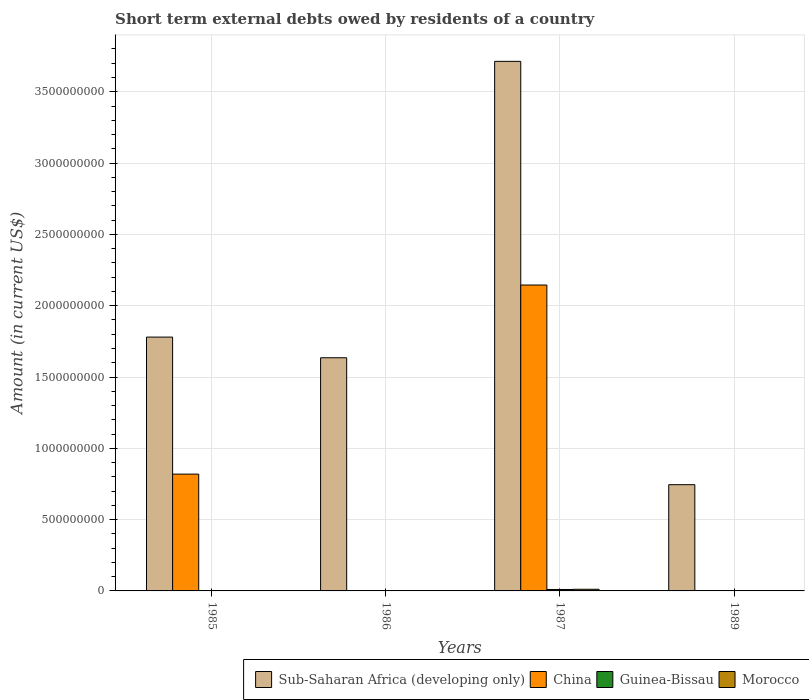How many different coloured bars are there?
Provide a succinct answer. 4. How many bars are there on the 3rd tick from the right?
Keep it short and to the point. 1. What is the label of the 2nd group of bars from the left?
Offer a terse response. 1986. What is the amount of short-term external debts owed by residents in Sub-Saharan Africa (developing only) in 1986?
Keep it short and to the point. 1.63e+09. Across all years, what is the maximum amount of short-term external debts owed by residents in Sub-Saharan Africa (developing only)?
Provide a short and direct response. 3.71e+09. In which year was the amount of short-term external debts owed by residents in China maximum?
Provide a short and direct response. 1987. What is the total amount of short-term external debts owed by residents in China in the graph?
Make the answer very short. 2.96e+09. What is the difference between the amount of short-term external debts owed by residents in Sub-Saharan Africa (developing only) in 1985 and that in 1986?
Offer a terse response. 1.45e+08. What is the difference between the amount of short-term external debts owed by residents in China in 1987 and the amount of short-term external debts owed by residents in Guinea-Bissau in 1989?
Provide a short and direct response. 2.14e+09. What is the average amount of short-term external debts owed by residents in Sub-Saharan Africa (developing only) per year?
Your answer should be very brief. 1.97e+09. In the year 1987, what is the difference between the amount of short-term external debts owed by residents in China and amount of short-term external debts owed by residents in Guinea-Bissau?
Your answer should be very brief. 2.13e+09. In how many years, is the amount of short-term external debts owed by residents in Morocco greater than 1300000000 US$?
Ensure brevity in your answer.  0. What is the difference between the highest and the lowest amount of short-term external debts owed by residents in China?
Make the answer very short. 2.14e+09. Is the sum of the amount of short-term external debts owed by residents in Sub-Saharan Africa (developing only) in 1985 and 1986 greater than the maximum amount of short-term external debts owed by residents in Guinea-Bissau across all years?
Your answer should be compact. Yes. Is it the case that in every year, the sum of the amount of short-term external debts owed by residents in Sub-Saharan Africa (developing only) and amount of short-term external debts owed by residents in Morocco is greater than the sum of amount of short-term external debts owed by residents in Guinea-Bissau and amount of short-term external debts owed by residents in China?
Give a very brief answer. Yes. How many bars are there?
Provide a short and direct response. 8. How many years are there in the graph?
Keep it short and to the point. 4. Does the graph contain grids?
Your answer should be very brief. Yes. Where does the legend appear in the graph?
Give a very brief answer. Bottom right. How many legend labels are there?
Provide a short and direct response. 4. What is the title of the graph?
Make the answer very short. Short term external debts owed by residents of a country. Does "Kiribati" appear as one of the legend labels in the graph?
Keep it short and to the point. No. What is the Amount (in current US$) of Sub-Saharan Africa (developing only) in 1985?
Your response must be concise. 1.78e+09. What is the Amount (in current US$) of China in 1985?
Your response must be concise. 8.19e+08. What is the Amount (in current US$) in Morocco in 1985?
Your response must be concise. 0. What is the Amount (in current US$) in Sub-Saharan Africa (developing only) in 1986?
Ensure brevity in your answer.  1.63e+09. What is the Amount (in current US$) of Morocco in 1986?
Keep it short and to the point. 0. What is the Amount (in current US$) in Sub-Saharan Africa (developing only) in 1987?
Make the answer very short. 3.71e+09. What is the Amount (in current US$) of China in 1987?
Keep it short and to the point. 2.14e+09. What is the Amount (in current US$) of Guinea-Bissau in 1987?
Provide a short and direct response. 1.01e+07. What is the Amount (in current US$) in Morocco in 1987?
Offer a terse response. 1.15e+07. What is the Amount (in current US$) of Sub-Saharan Africa (developing only) in 1989?
Provide a succinct answer. 7.45e+08. What is the Amount (in current US$) in China in 1989?
Make the answer very short. 0. What is the Amount (in current US$) in Morocco in 1989?
Your answer should be very brief. 0. Across all years, what is the maximum Amount (in current US$) in Sub-Saharan Africa (developing only)?
Make the answer very short. 3.71e+09. Across all years, what is the maximum Amount (in current US$) of China?
Offer a terse response. 2.14e+09. Across all years, what is the maximum Amount (in current US$) in Guinea-Bissau?
Make the answer very short. 1.01e+07. Across all years, what is the maximum Amount (in current US$) of Morocco?
Provide a succinct answer. 1.15e+07. Across all years, what is the minimum Amount (in current US$) of Sub-Saharan Africa (developing only)?
Make the answer very short. 7.45e+08. Across all years, what is the minimum Amount (in current US$) in China?
Give a very brief answer. 0. What is the total Amount (in current US$) in Sub-Saharan Africa (developing only) in the graph?
Keep it short and to the point. 7.87e+09. What is the total Amount (in current US$) of China in the graph?
Your answer should be very brief. 2.96e+09. What is the total Amount (in current US$) in Guinea-Bissau in the graph?
Your answer should be very brief. 1.01e+07. What is the total Amount (in current US$) of Morocco in the graph?
Offer a terse response. 1.15e+07. What is the difference between the Amount (in current US$) of Sub-Saharan Africa (developing only) in 1985 and that in 1986?
Provide a short and direct response. 1.45e+08. What is the difference between the Amount (in current US$) in Sub-Saharan Africa (developing only) in 1985 and that in 1987?
Provide a succinct answer. -1.93e+09. What is the difference between the Amount (in current US$) of China in 1985 and that in 1987?
Keep it short and to the point. -1.33e+09. What is the difference between the Amount (in current US$) in Sub-Saharan Africa (developing only) in 1985 and that in 1989?
Give a very brief answer. 1.03e+09. What is the difference between the Amount (in current US$) in Sub-Saharan Africa (developing only) in 1986 and that in 1987?
Ensure brevity in your answer.  -2.08e+09. What is the difference between the Amount (in current US$) in Sub-Saharan Africa (developing only) in 1986 and that in 1989?
Keep it short and to the point. 8.90e+08. What is the difference between the Amount (in current US$) of Sub-Saharan Africa (developing only) in 1987 and that in 1989?
Offer a terse response. 2.97e+09. What is the difference between the Amount (in current US$) of Sub-Saharan Africa (developing only) in 1985 and the Amount (in current US$) of China in 1987?
Provide a succinct answer. -3.65e+08. What is the difference between the Amount (in current US$) of Sub-Saharan Africa (developing only) in 1985 and the Amount (in current US$) of Guinea-Bissau in 1987?
Offer a very short reply. 1.77e+09. What is the difference between the Amount (in current US$) in Sub-Saharan Africa (developing only) in 1985 and the Amount (in current US$) in Morocco in 1987?
Your answer should be very brief. 1.77e+09. What is the difference between the Amount (in current US$) in China in 1985 and the Amount (in current US$) in Guinea-Bissau in 1987?
Provide a short and direct response. 8.09e+08. What is the difference between the Amount (in current US$) in China in 1985 and the Amount (in current US$) in Morocco in 1987?
Offer a very short reply. 8.08e+08. What is the difference between the Amount (in current US$) in Sub-Saharan Africa (developing only) in 1986 and the Amount (in current US$) in China in 1987?
Offer a very short reply. -5.10e+08. What is the difference between the Amount (in current US$) in Sub-Saharan Africa (developing only) in 1986 and the Amount (in current US$) in Guinea-Bissau in 1987?
Give a very brief answer. 1.62e+09. What is the difference between the Amount (in current US$) of Sub-Saharan Africa (developing only) in 1986 and the Amount (in current US$) of Morocco in 1987?
Your answer should be very brief. 1.62e+09. What is the average Amount (in current US$) of Sub-Saharan Africa (developing only) per year?
Ensure brevity in your answer.  1.97e+09. What is the average Amount (in current US$) in China per year?
Make the answer very short. 7.41e+08. What is the average Amount (in current US$) of Guinea-Bissau per year?
Make the answer very short. 2.53e+06. What is the average Amount (in current US$) in Morocco per year?
Provide a short and direct response. 2.88e+06. In the year 1985, what is the difference between the Amount (in current US$) of Sub-Saharan Africa (developing only) and Amount (in current US$) of China?
Make the answer very short. 9.61e+08. In the year 1987, what is the difference between the Amount (in current US$) in Sub-Saharan Africa (developing only) and Amount (in current US$) in China?
Make the answer very short. 1.57e+09. In the year 1987, what is the difference between the Amount (in current US$) in Sub-Saharan Africa (developing only) and Amount (in current US$) in Guinea-Bissau?
Provide a succinct answer. 3.70e+09. In the year 1987, what is the difference between the Amount (in current US$) in Sub-Saharan Africa (developing only) and Amount (in current US$) in Morocco?
Ensure brevity in your answer.  3.70e+09. In the year 1987, what is the difference between the Amount (in current US$) in China and Amount (in current US$) in Guinea-Bissau?
Ensure brevity in your answer.  2.13e+09. In the year 1987, what is the difference between the Amount (in current US$) in China and Amount (in current US$) in Morocco?
Your answer should be very brief. 2.13e+09. In the year 1987, what is the difference between the Amount (in current US$) of Guinea-Bissau and Amount (in current US$) of Morocco?
Keep it short and to the point. -1.38e+06. What is the ratio of the Amount (in current US$) in Sub-Saharan Africa (developing only) in 1985 to that in 1986?
Keep it short and to the point. 1.09. What is the ratio of the Amount (in current US$) of Sub-Saharan Africa (developing only) in 1985 to that in 1987?
Offer a very short reply. 0.48. What is the ratio of the Amount (in current US$) of China in 1985 to that in 1987?
Offer a very short reply. 0.38. What is the ratio of the Amount (in current US$) in Sub-Saharan Africa (developing only) in 1985 to that in 1989?
Your answer should be very brief. 2.39. What is the ratio of the Amount (in current US$) in Sub-Saharan Africa (developing only) in 1986 to that in 1987?
Make the answer very short. 0.44. What is the ratio of the Amount (in current US$) in Sub-Saharan Africa (developing only) in 1986 to that in 1989?
Make the answer very short. 2.19. What is the ratio of the Amount (in current US$) of Sub-Saharan Africa (developing only) in 1987 to that in 1989?
Keep it short and to the point. 4.98. What is the difference between the highest and the second highest Amount (in current US$) of Sub-Saharan Africa (developing only)?
Make the answer very short. 1.93e+09. What is the difference between the highest and the lowest Amount (in current US$) of Sub-Saharan Africa (developing only)?
Keep it short and to the point. 2.97e+09. What is the difference between the highest and the lowest Amount (in current US$) of China?
Your answer should be very brief. 2.14e+09. What is the difference between the highest and the lowest Amount (in current US$) in Guinea-Bissau?
Provide a succinct answer. 1.01e+07. What is the difference between the highest and the lowest Amount (in current US$) of Morocco?
Offer a very short reply. 1.15e+07. 